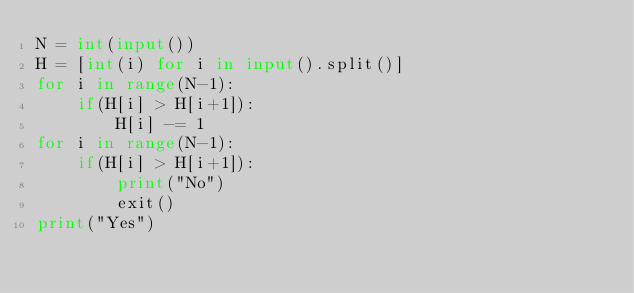Convert code to text. <code><loc_0><loc_0><loc_500><loc_500><_Python_>N = int(input())
H = [int(i) for i in input().split()]
for i in range(N-1):
    if(H[i] > H[i+1]):
        H[i] -= 1
for i in range(N-1):
    if(H[i] > H[i+1]):
        print("No")
        exit()
print("Yes")</code> 